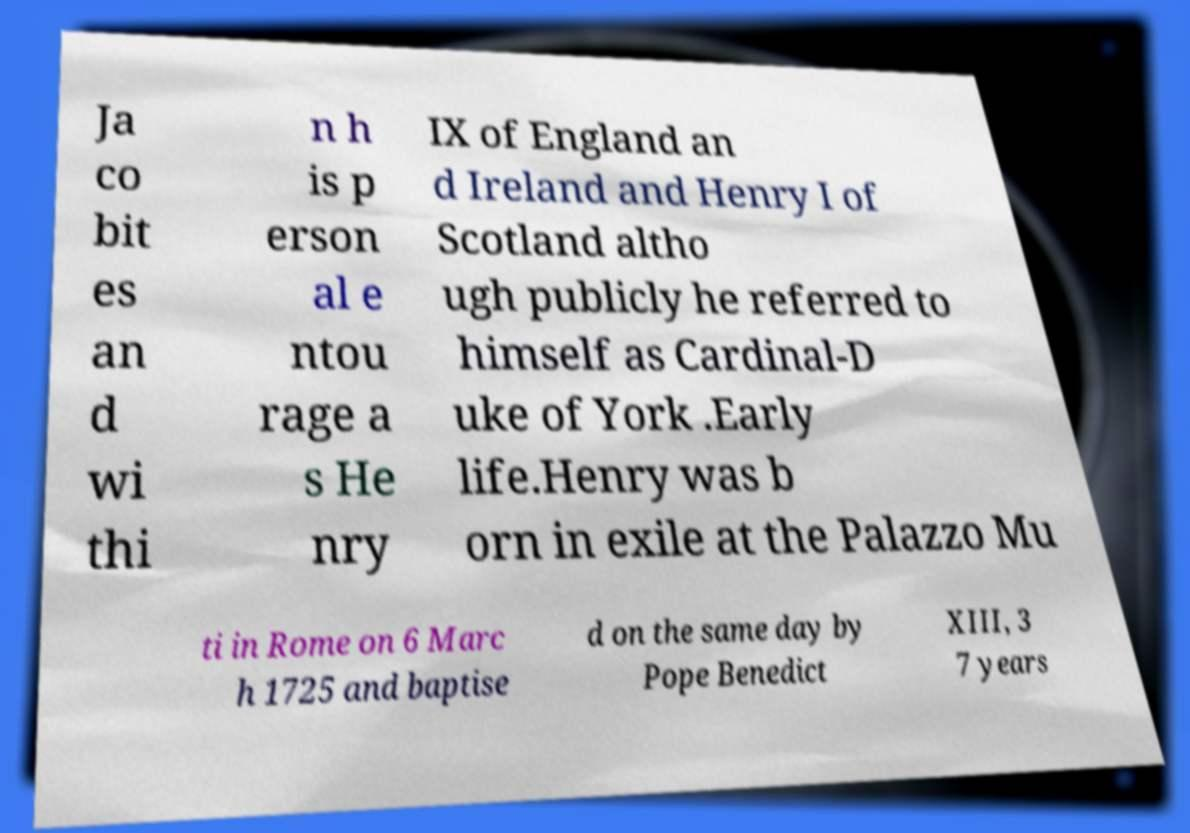What messages or text are displayed in this image? I need them in a readable, typed format. Ja co bit es an d wi thi n h is p erson al e ntou rage a s He nry IX of England an d Ireland and Henry I of Scotland altho ugh publicly he referred to himself as Cardinal-D uke of York .Early life.Henry was b orn in exile at the Palazzo Mu ti in Rome on 6 Marc h 1725 and baptise d on the same day by Pope Benedict XIII, 3 7 years 